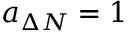<formula> <loc_0><loc_0><loc_500><loc_500>a _ { \Delta N } = 1</formula> 